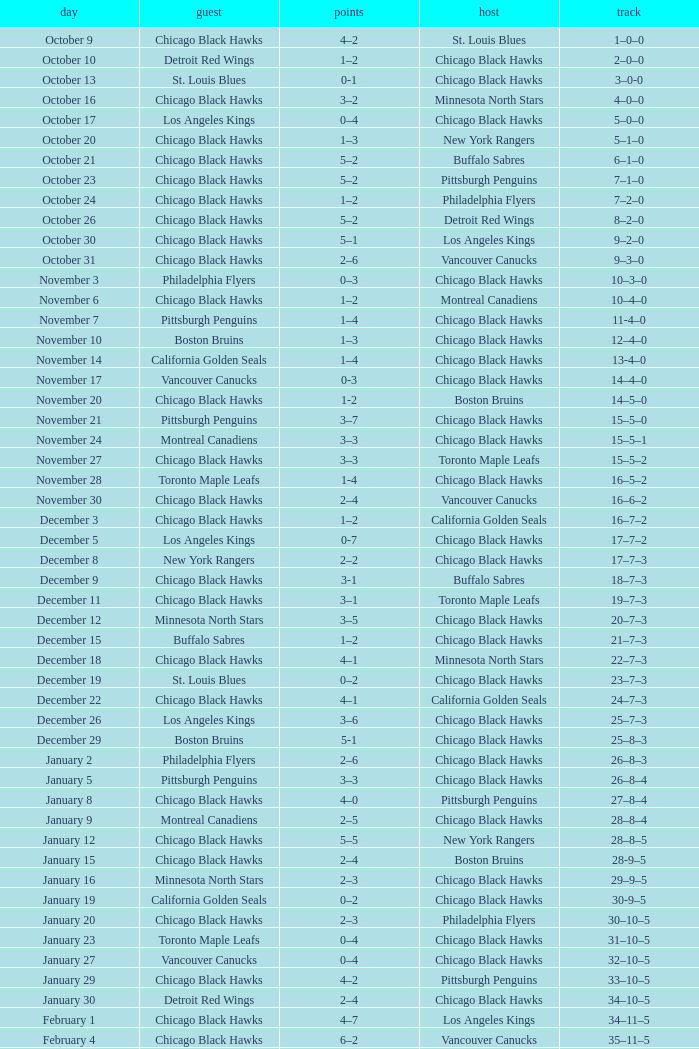What is the Record from February 10? 36–13–5. 